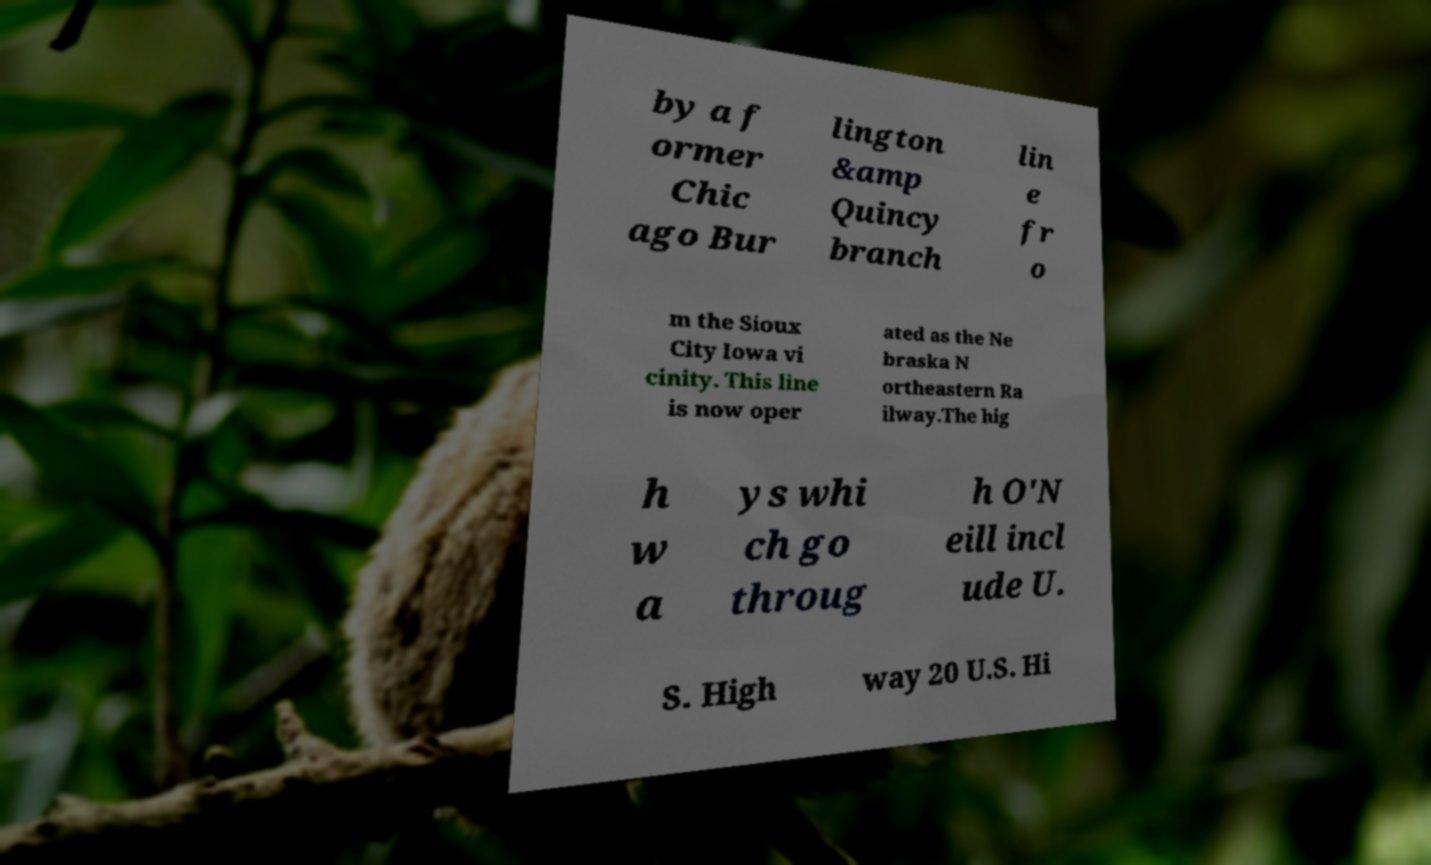Can you read and provide the text displayed in the image?This photo seems to have some interesting text. Can you extract and type it out for me? by a f ormer Chic ago Bur lington &amp Quincy branch lin e fr o m the Sioux City Iowa vi cinity. This line is now oper ated as the Ne braska N ortheastern Ra ilway.The hig h w a ys whi ch go throug h O'N eill incl ude U. S. High way 20 U.S. Hi 